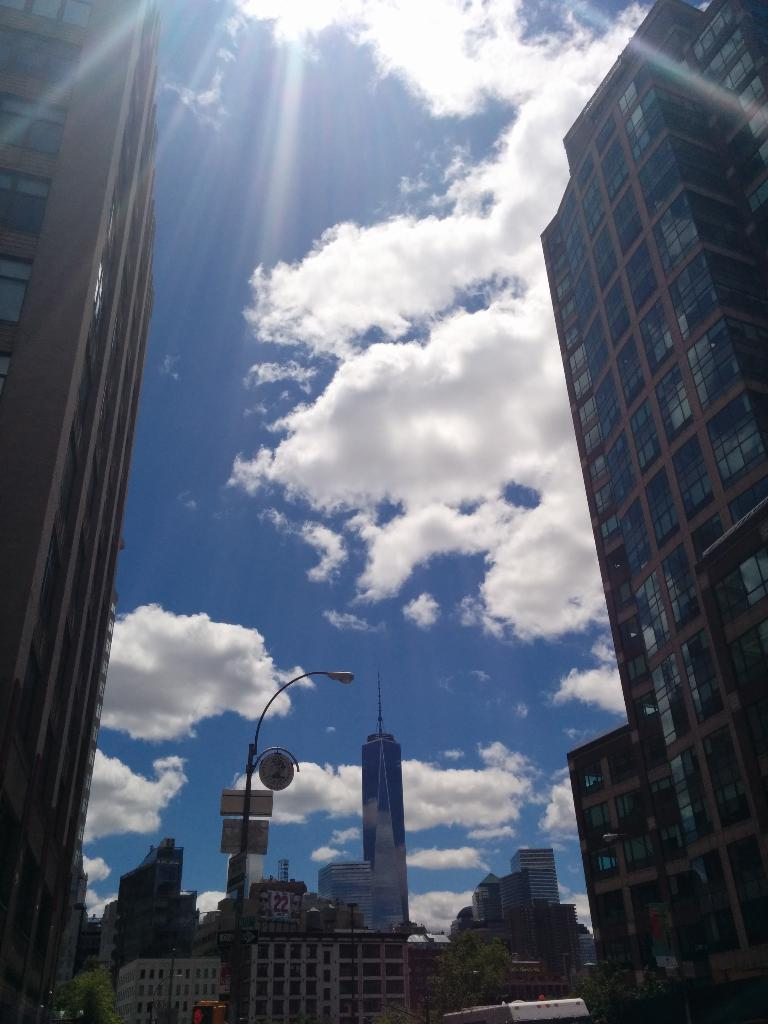What type of structures can be seen in the image? There are buildings in the image. What other natural elements are present in the image? There are trees in the image. Can you describe any specific objects in the image? There is a pole and name boards in the image. What else can be seen in the image besides the buildings, trees, and objects? There are other objects in the image. What is visible in the background of the image? The sky is visible in the background of the image, and clouds are present in the sky. Can you tell me how many eggs are on the pole in the image? There are no eggs present in the image; the pole has name boards on it. What type of dog can be seen playing with the trees in the image? There is no dog present in the image; it features buildings, trees, and a pole with name boards. 